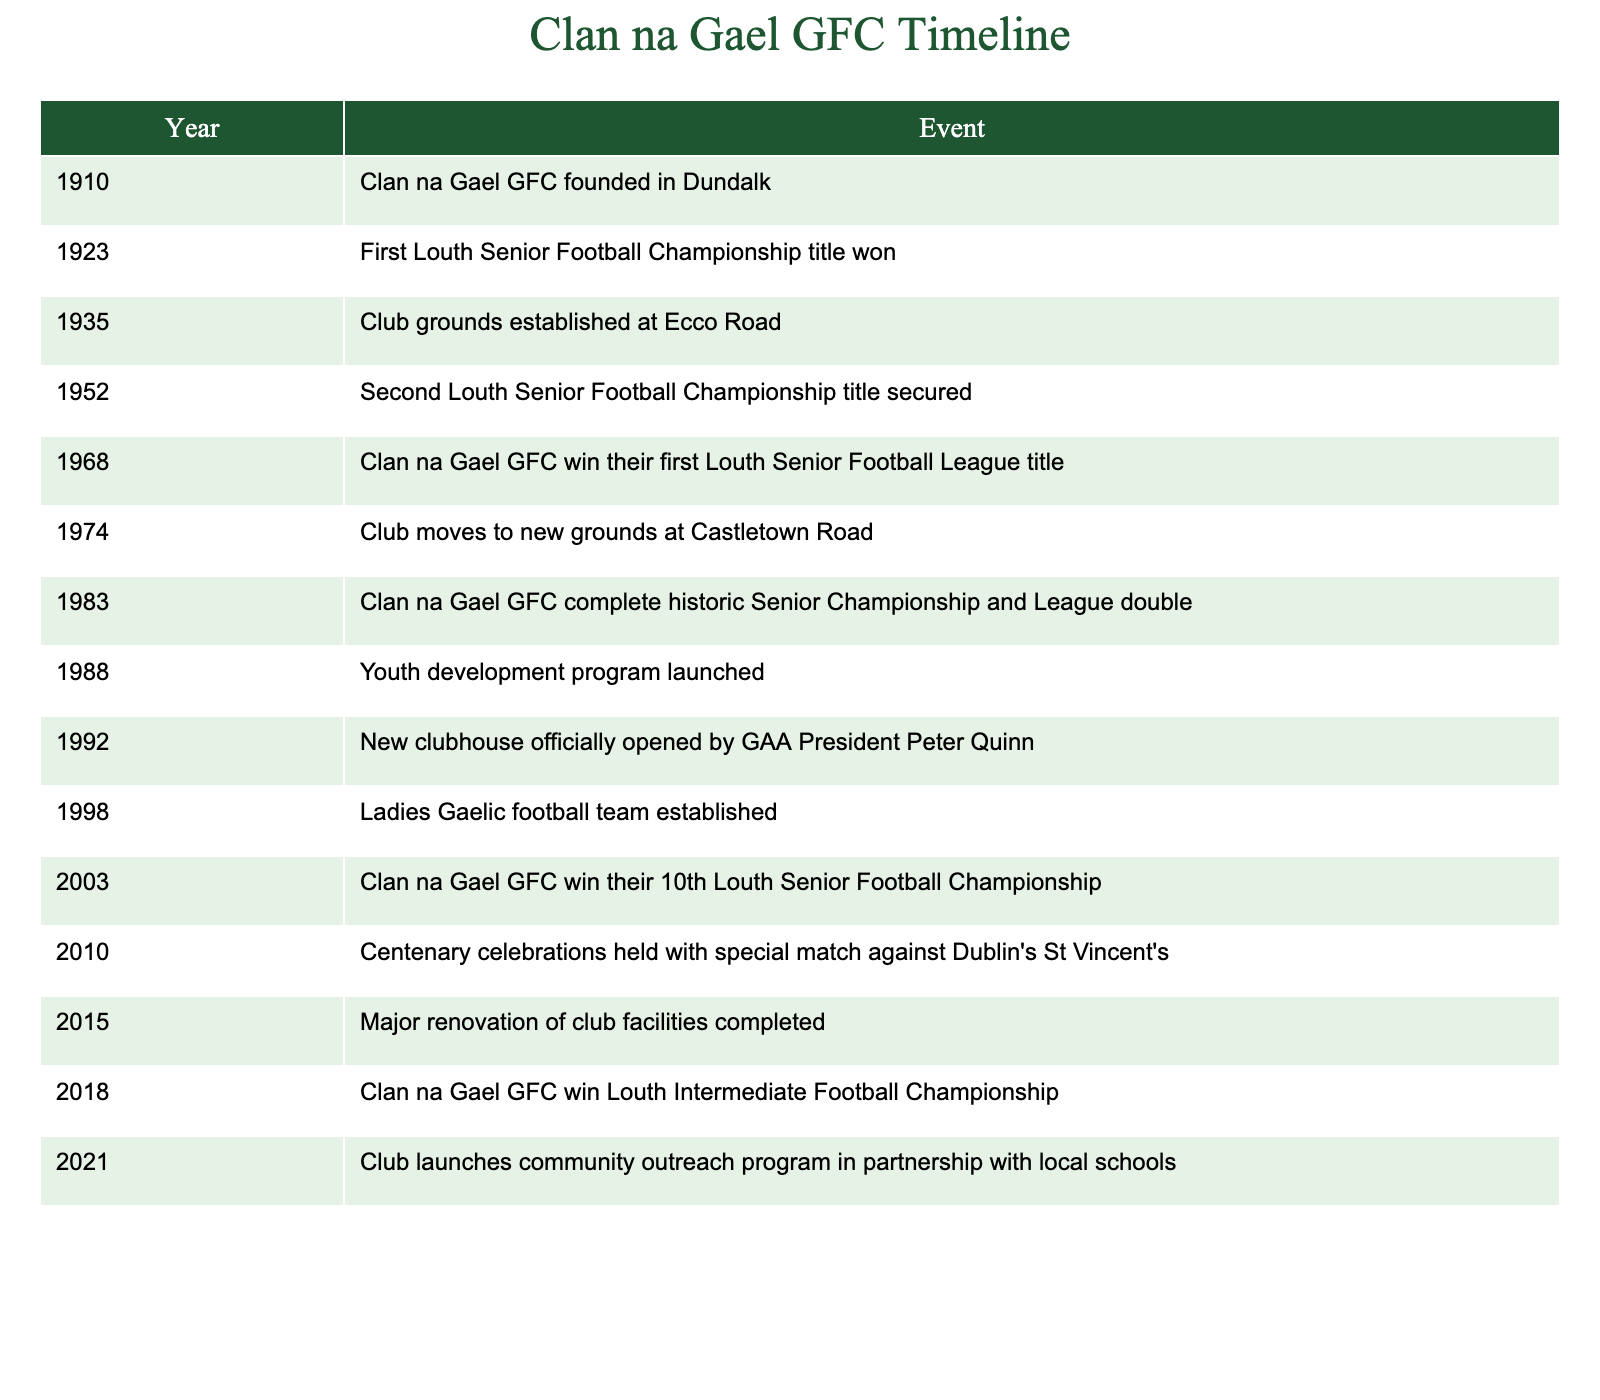What year was Clan na Gael GFC founded? The table lists the founding year of Clan na Gael GFC as 1910 in the first row under the "Year" column.
Answer: 1910 How many Louth Senior Football Championship titles did Clan na Gael GFC win by 1952? By checking the years 1923 and 1952 in the table, the club won the championship in 1923 and again in 1952, making it a total of 2 titles by that year.
Answer: 2 What significant event occurred for Clan na Gael GFC in 1983? The table specifies that in 1983, the club completed a historic Senior Championship and League double. This means they won both the championship and the league title in the same year.
Answer: Completion of a historic double In what year did Clan na Gael GFC establish its ladies Gaelic football team? The table indicates that the ladies Gaelic football team was established in 1998, as shown in the corresponding row under the "Event" column.
Answer: 1998 Was there a community outreach program launched before 2021? The table only shows the launch of the community outreach program in 2021, with no earlier instance mentioned, confirming that no such program was launched before this year.
Answer: No What is the difference in years between the establishment of the club grounds at Ecco Road and the club moving to new grounds at Castletown Road? The club grounds at Ecco Road were established in 1935, and the move to Castletown Road occurred in 1974. The difference is calculated as 1974 - 1935, which equals 39 years.
Answer: 39 years What was the most recent event listed in the table? The last row in the table lists the launch of a community outreach program in 2021, indicating this was the most recent event.
Answer: 2021 How many years after the club's founding did it win its first Louth Senior Football League title? Clan na Gael GFC was founded in 1910, and it won its first Louth Senior Football League title in 1968. The difference is 1968 - 1910, leading to 58 years.
Answer: 58 years What milestone event took place during Clan na Gael GFC's centenary celebrations? The centenary celebrations in 2010 included a special match against Dublin's St Vincent's, which is specifically mentioned in the events listed in the respective year.
Answer: Special match against St Vincent's 